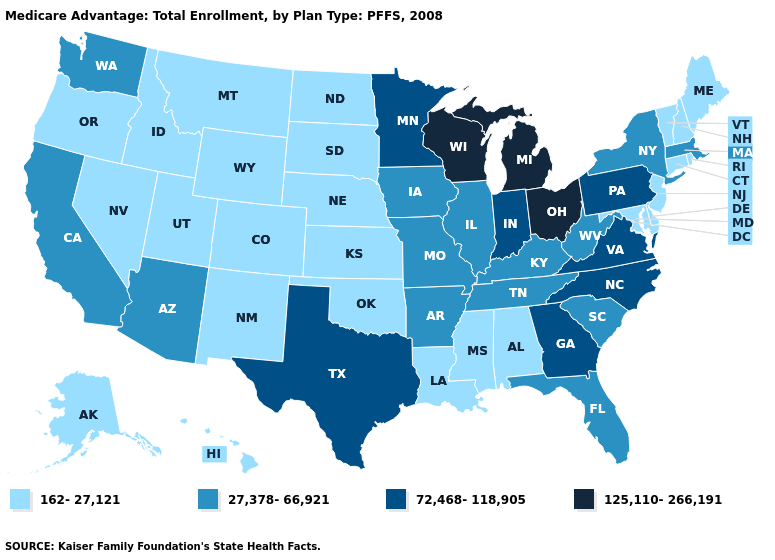Name the states that have a value in the range 27,378-66,921?
Write a very short answer. Arkansas, Arizona, California, Florida, Iowa, Illinois, Kentucky, Massachusetts, Missouri, New York, South Carolina, Tennessee, Washington, West Virginia. Name the states that have a value in the range 125,110-266,191?
Write a very short answer. Michigan, Ohio, Wisconsin. Does New Hampshire have a higher value than Tennessee?
Give a very brief answer. No. Among the states that border Illinois , does Wisconsin have the highest value?
Concise answer only. Yes. What is the highest value in states that border Georgia?
Give a very brief answer. 72,468-118,905. Name the states that have a value in the range 27,378-66,921?
Keep it brief. Arkansas, Arizona, California, Florida, Iowa, Illinois, Kentucky, Massachusetts, Missouri, New York, South Carolina, Tennessee, Washington, West Virginia. What is the value of Tennessee?
Write a very short answer. 27,378-66,921. Name the states that have a value in the range 125,110-266,191?
Write a very short answer. Michigan, Ohio, Wisconsin. What is the value of Arizona?
Give a very brief answer. 27,378-66,921. What is the value of California?
Write a very short answer. 27,378-66,921. What is the value of Mississippi?
Write a very short answer. 162-27,121. Name the states that have a value in the range 125,110-266,191?
Quick response, please. Michigan, Ohio, Wisconsin. Does Michigan have the highest value in the MidWest?
Short answer required. Yes. What is the value of Hawaii?
Keep it brief. 162-27,121. What is the value of Ohio?
Write a very short answer. 125,110-266,191. 